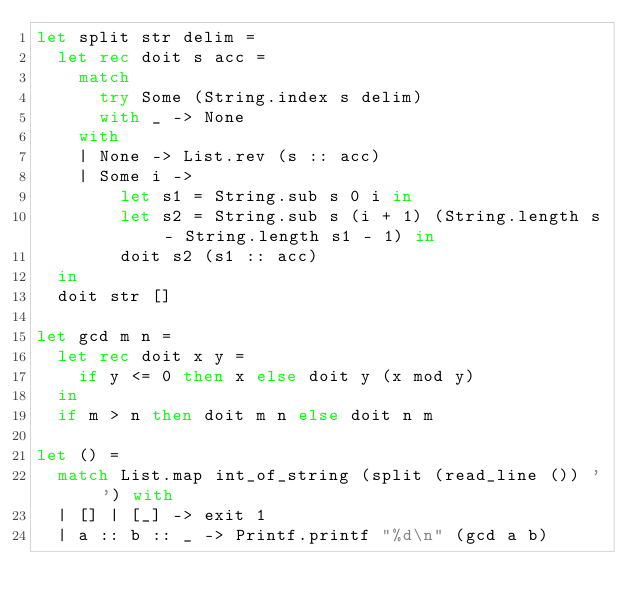<code> <loc_0><loc_0><loc_500><loc_500><_OCaml_>let split str delim =
  let rec doit s acc =
    match
      try Some (String.index s delim)
      with _ -> None
    with
    | None -> List.rev (s :: acc)
    | Some i ->
        let s1 = String.sub s 0 i in
        let s2 = String.sub s (i + 1) (String.length s - String.length s1 - 1) in
        doit s2 (s1 :: acc)
  in
  doit str []

let gcd m n =
  let rec doit x y =
    if y <= 0 then x else doit y (x mod y)
  in
  if m > n then doit m n else doit n m

let () =
  match List.map int_of_string (split (read_line ()) ' ') with
  | [] | [_] -> exit 1
  | a :: b :: _ -> Printf.printf "%d\n" (gcd a b)</code> 